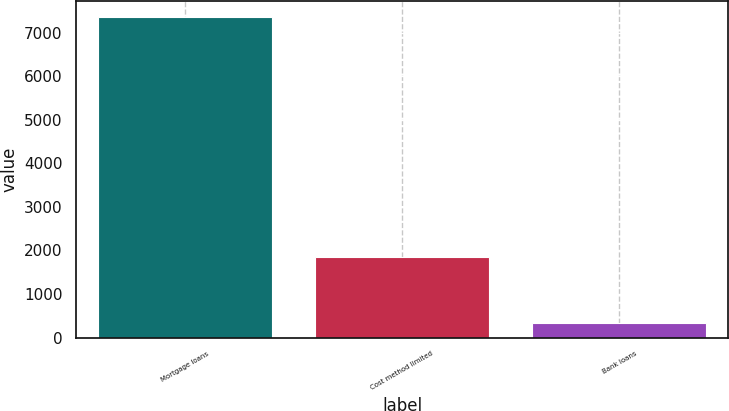<chart> <loc_0><loc_0><loc_500><loc_500><bar_chart><fcel>Mortgage loans<fcel>Cost method limited<fcel>Bank loans<nl><fcel>7350<fcel>1838<fcel>328<nl></chart> 